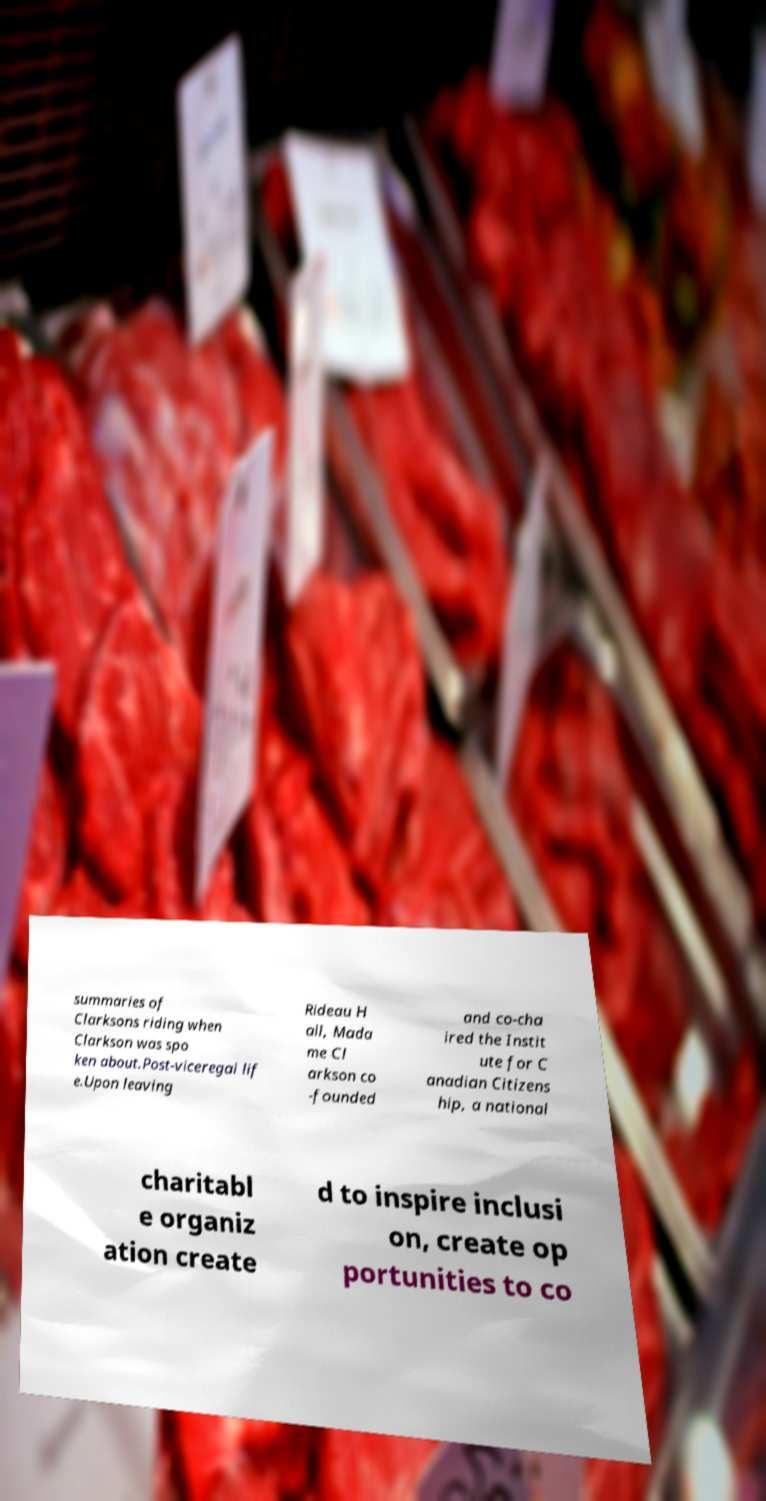There's text embedded in this image that I need extracted. Can you transcribe it verbatim? summaries of Clarksons riding when Clarkson was spo ken about.Post-viceregal lif e.Upon leaving Rideau H all, Mada me Cl arkson co -founded and co-cha ired the Instit ute for C anadian Citizens hip, a national charitabl e organiz ation create d to inspire inclusi on, create op portunities to co 